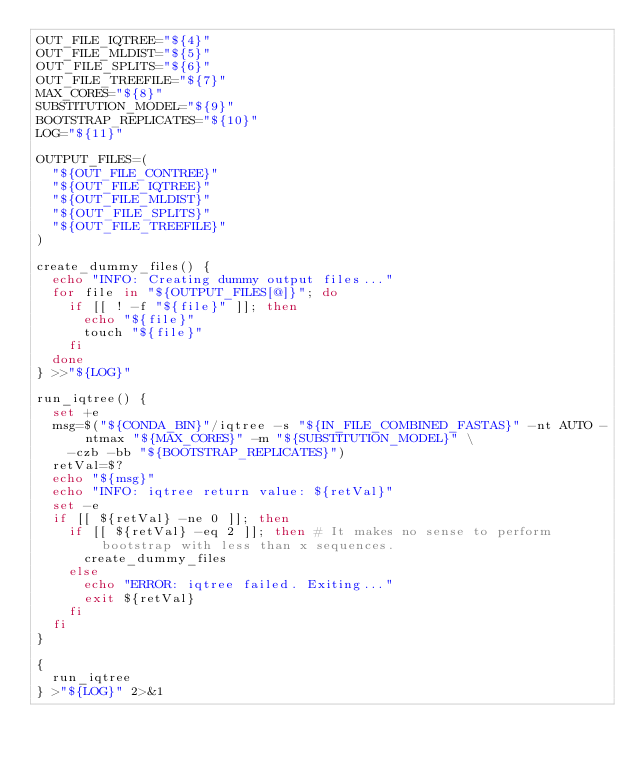<code> <loc_0><loc_0><loc_500><loc_500><_Bash_>OUT_FILE_IQTREE="${4}"
OUT_FILE_MLDIST="${5}"
OUT_FILE_SPLITS="${6}"
OUT_FILE_TREEFILE="${7}"
MAX_CORES="${8}"
SUBSTITUTION_MODEL="${9}"
BOOTSTRAP_REPLICATES="${10}"
LOG="${11}"

OUTPUT_FILES=(
  "${OUT_FILE_CONTREE}"
  "${OUT_FILE_IQTREE}"
  "${OUT_FILE_MLDIST}"
  "${OUT_FILE_SPLITS}"
  "${OUT_FILE_TREEFILE}"
)

create_dummy_files() {
  echo "INFO: Creating dummy output files..."
  for file in "${OUTPUT_FILES[@]}"; do
    if [[ ! -f "${file}" ]]; then
      echo "${file}"
      touch "${file}"
    fi
  done
} >>"${LOG}"

run_iqtree() {
  set +e
  msg=$("${CONDA_BIN}"/iqtree -s "${IN_FILE_COMBINED_FASTAS}" -nt AUTO -ntmax "${MAX_CORES}" -m "${SUBSTITUTION_MODEL}" \
    -czb -bb "${BOOTSTRAP_REPLICATES}")
  retVal=$?
  echo "${msg}"
  echo "INFO: iqtree return value: ${retVal}"
  set -e
  if [[ ${retVal} -ne 0 ]]; then
    if [[ ${retVal} -eq 2 ]]; then # It makes no sense to perform bootstrap with less than x sequences.
      create_dummy_files
    else
      echo "ERROR: iqtree failed. Exiting..."
      exit ${retVal}
    fi
  fi
}

{
  run_iqtree
} >"${LOG}" 2>&1
</code> 